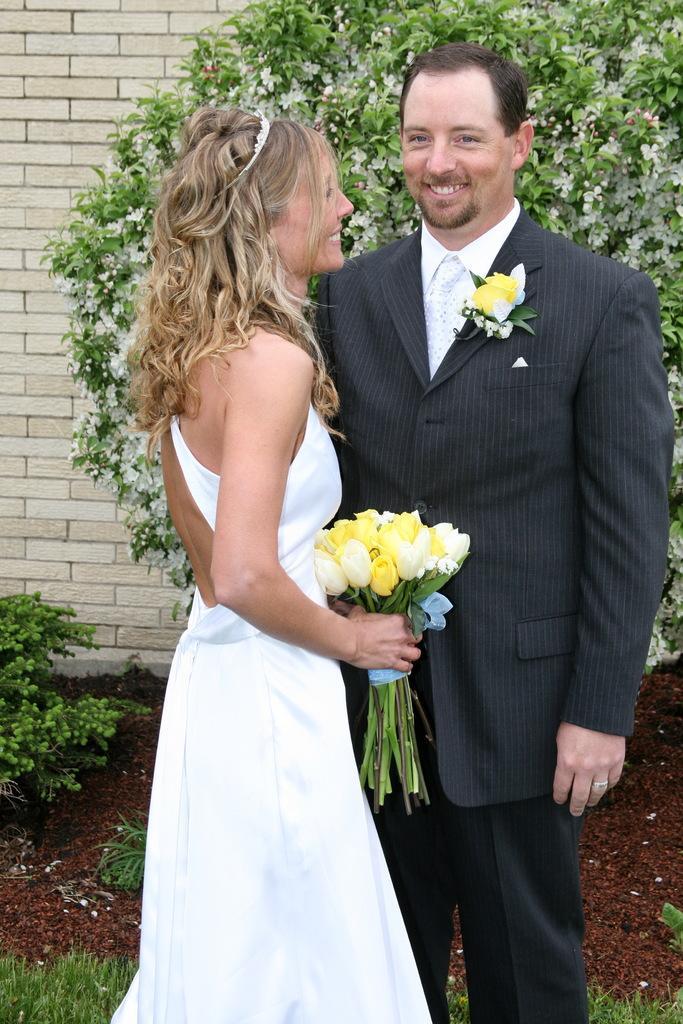Please provide a concise description of this image. In the middle of the image two persons are standing and smiling and holding some flowers. Behind them there are some plants and wall. 